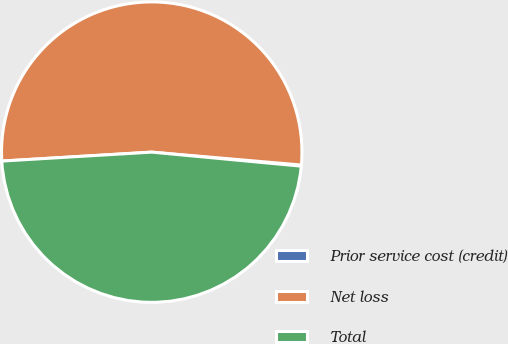Convert chart to OTSL. <chart><loc_0><loc_0><loc_500><loc_500><pie_chart><fcel>Prior service cost (credit)<fcel>Net loss<fcel>Total<nl><fcel>0.12%<fcel>52.32%<fcel>47.56%<nl></chart> 